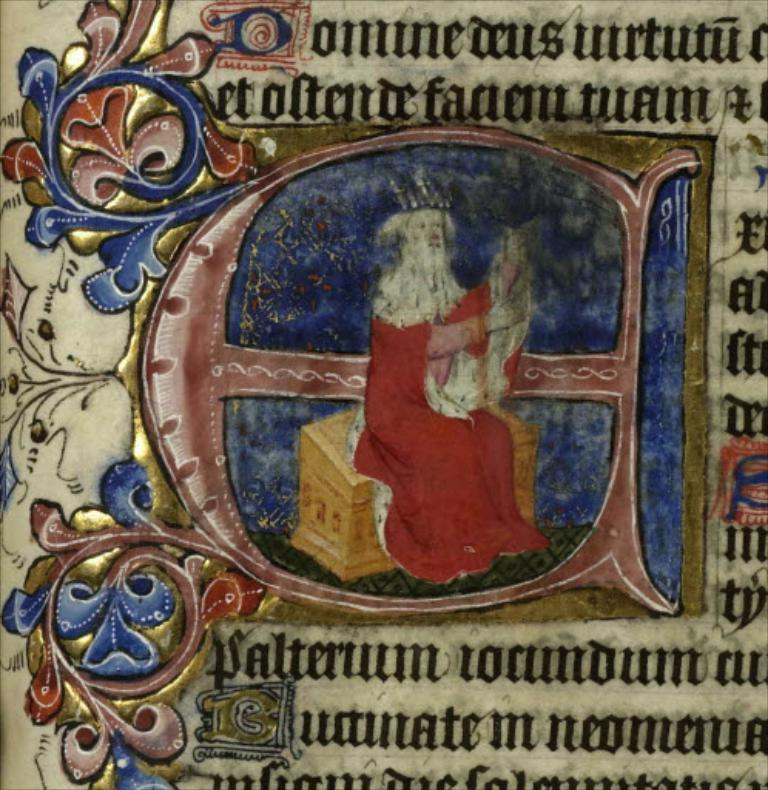What is the main object in the image? There is a stone in the image. What is written or depicted on the stone? There is text and pictures engraved on the stone. Who is present in the image? There is a person in the center of the image. What is the person holding? The person is holding something. What is the person wearing? The person is wearing a red dress. How does the person in the image use their nose to pull the stone? The person in the image is not using their nose to pull the stone; there is no indication of any pulling action in the image. 